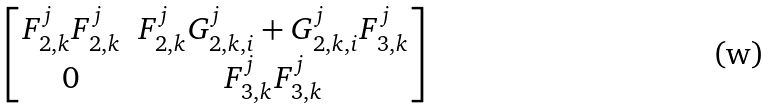<formula> <loc_0><loc_0><loc_500><loc_500>\begin{bmatrix} F _ { 2 , k } ^ { j } F _ { 2 , k } ^ { j } & F _ { 2 , k } ^ { j } G _ { 2 , k , i } ^ { j } + G _ { 2 , k , i } ^ { j } F _ { 3 , k } ^ { j } \\ 0 & F _ { 3 , k } ^ { j } F _ { 3 , k } ^ { j } \end{bmatrix}</formula> 